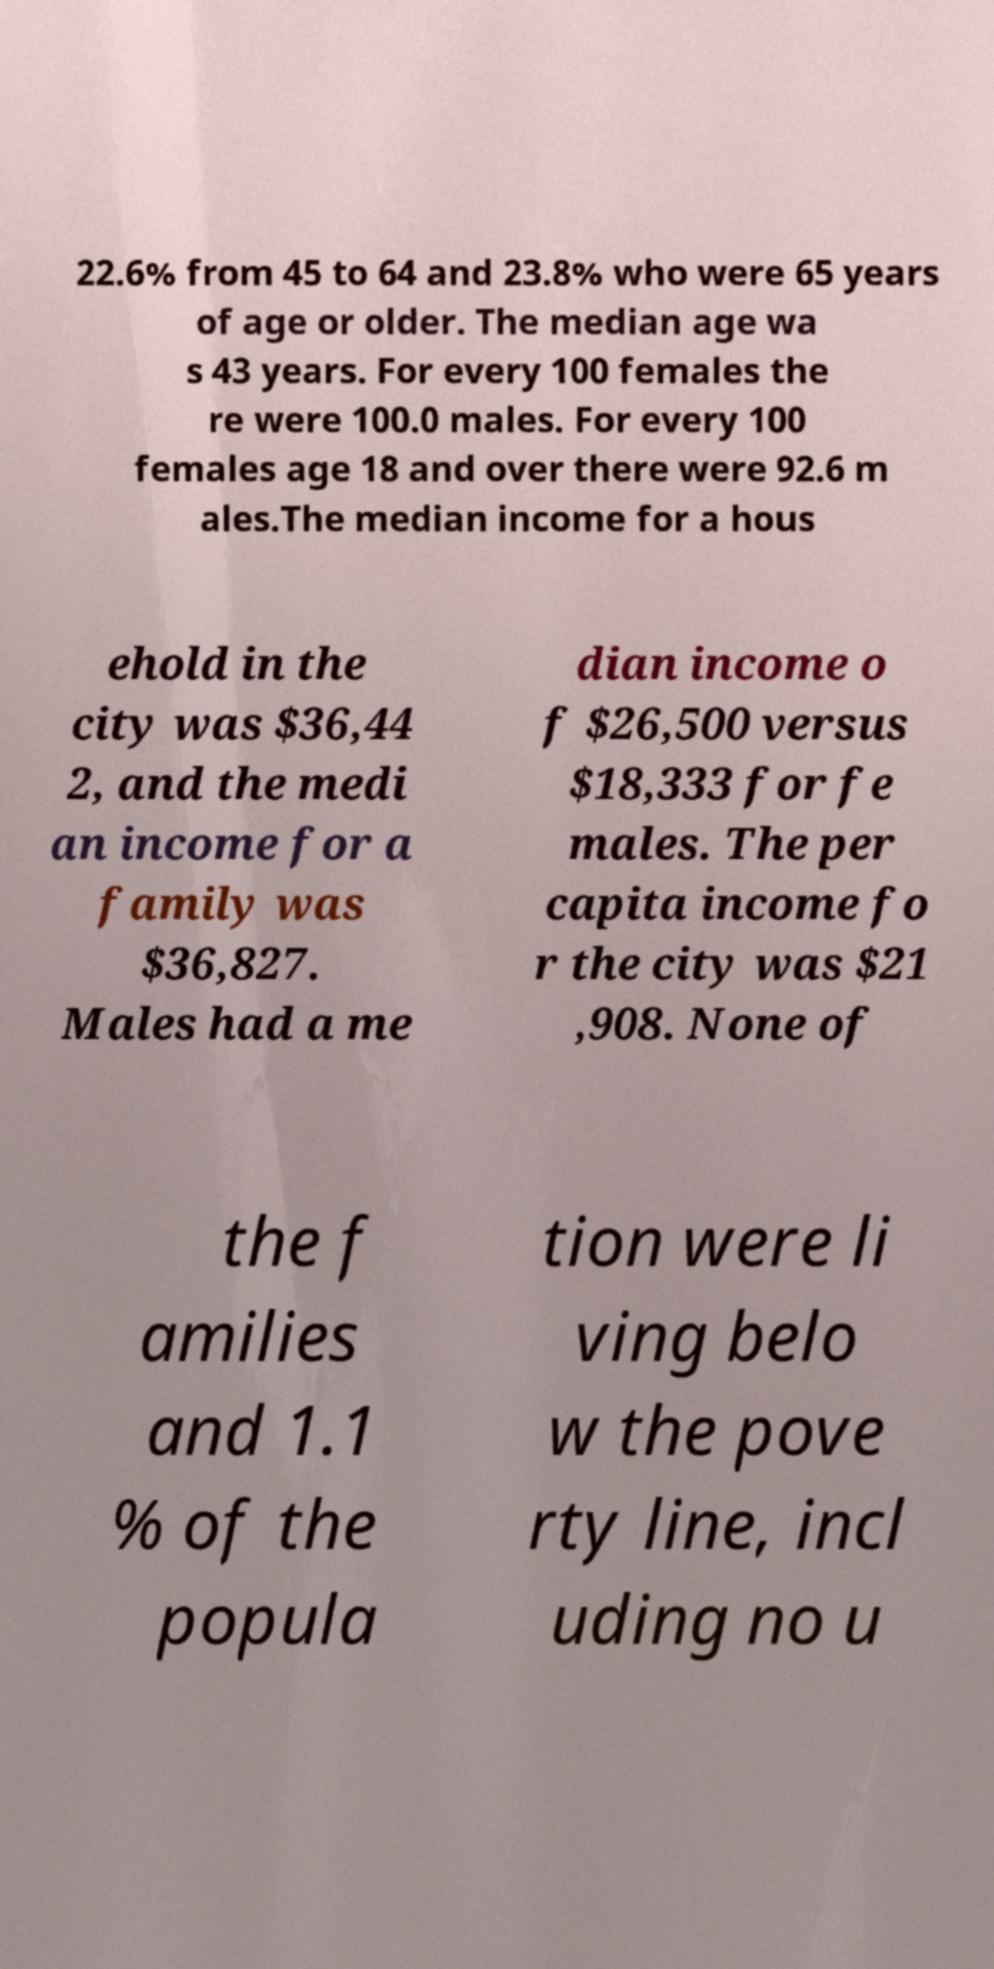Can you read and provide the text displayed in the image?This photo seems to have some interesting text. Can you extract and type it out for me? 22.6% from 45 to 64 and 23.8% who were 65 years of age or older. The median age wa s 43 years. For every 100 females the re were 100.0 males. For every 100 females age 18 and over there were 92.6 m ales.The median income for a hous ehold in the city was $36,44 2, and the medi an income for a family was $36,827. Males had a me dian income o f $26,500 versus $18,333 for fe males. The per capita income fo r the city was $21 ,908. None of the f amilies and 1.1 % of the popula tion were li ving belo w the pove rty line, incl uding no u 